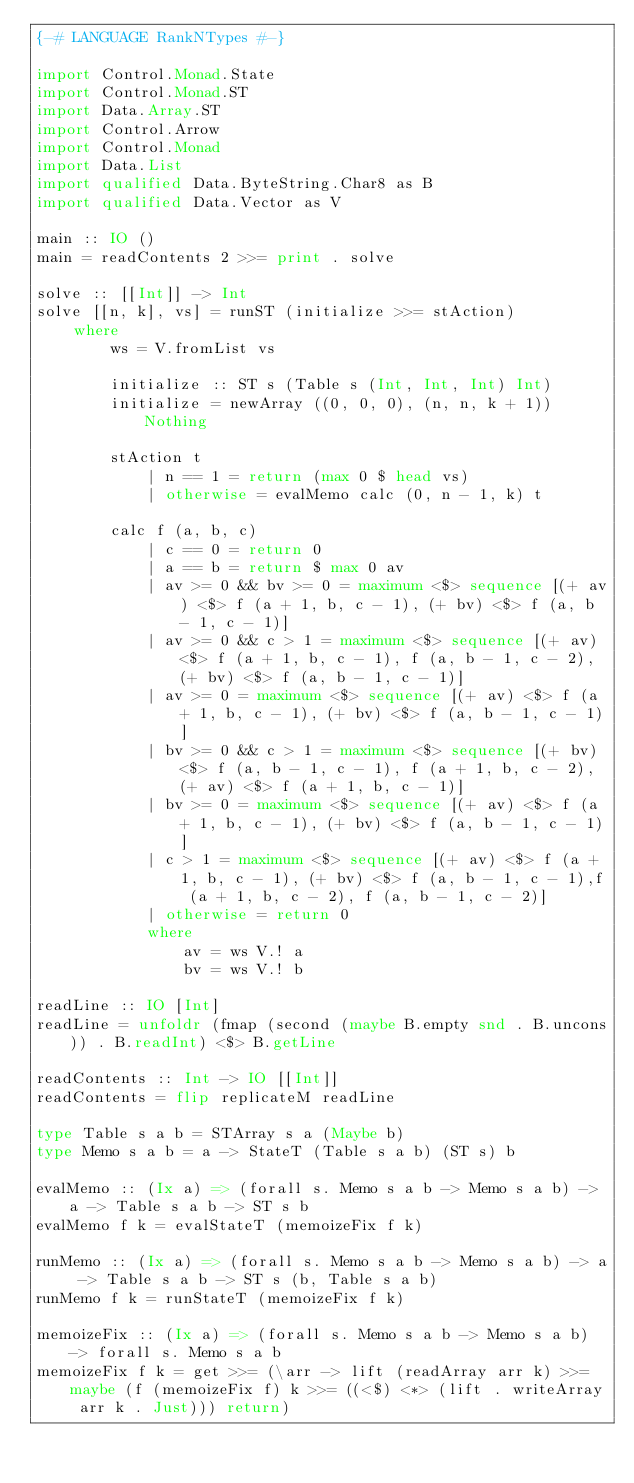Convert code to text. <code><loc_0><loc_0><loc_500><loc_500><_Haskell_>{-# LANGUAGE RankNTypes #-}
    
import Control.Monad.State
import Control.Monad.ST
import Data.Array.ST
import Control.Arrow
import Control.Monad
import Data.List
import qualified Data.ByteString.Char8 as B
import qualified Data.Vector as V

main :: IO ()
main = readContents 2 >>= print . solve

solve :: [[Int]] -> Int
solve [[n, k], vs] = runST (initialize >>= stAction)
    where
        ws = V.fromList vs

        initialize :: ST s (Table s (Int, Int, Int) Int)
        initialize = newArray ((0, 0, 0), (n, n, k + 1)) Nothing
        
        stAction t 
            | n == 1 = return (max 0 $ head vs)
            | otherwise = evalMemo calc (0, n - 1, k) t 

        calc f (a, b, c)
            | c == 0 = return 0
            | a == b = return $ max 0 av 
            | av >= 0 && bv >= 0 = maximum <$> sequence [(+ av) <$> f (a + 1, b, c - 1), (+ bv) <$> f (a, b - 1, c - 1)]
            | av >= 0 && c > 1 = maximum <$> sequence [(+ av) <$> f (a + 1, b, c - 1), f (a, b - 1, c - 2), (+ bv) <$> f (a, b - 1, c - 1)]
            | av >= 0 = maximum <$> sequence [(+ av) <$> f (a + 1, b, c - 1), (+ bv) <$> f (a, b - 1, c - 1)]
            | bv >= 0 && c > 1 = maximum <$> sequence [(+ bv) <$> f (a, b - 1, c - 1), f (a + 1, b, c - 2), (+ av) <$> f (a + 1, b, c - 1)]
            | bv >= 0 = maximum <$> sequence [(+ av) <$> f (a + 1, b, c - 1), (+ bv) <$> f (a, b - 1, c - 1)]
            | c > 1 = maximum <$> sequence [(+ av) <$> f (a + 1, b, c - 1), (+ bv) <$> f (a, b - 1, c - 1),f (a + 1, b, c - 2), f (a, b - 1, c - 2)]
            | otherwise = return 0
            where
                av = ws V.! a
                bv = ws V.! b

readLine :: IO [Int]
readLine = unfoldr (fmap (second (maybe B.empty snd . B.uncons)) . B.readInt) <$> B.getLine

readContents :: Int -> IO [[Int]]
readContents = flip replicateM readLine

type Table s a b = STArray s a (Maybe b)
type Memo s a b = a -> StateT (Table s a b) (ST s) b

evalMemo :: (Ix a) => (forall s. Memo s a b -> Memo s a b) -> a -> Table s a b -> ST s b
evalMemo f k = evalStateT (memoizeFix f k)

runMemo :: (Ix a) => (forall s. Memo s a b -> Memo s a b) -> a -> Table s a b -> ST s (b, Table s a b)
runMemo f k = runStateT (memoizeFix f k)

memoizeFix :: (Ix a) => (forall s. Memo s a b -> Memo s a b) -> forall s. Memo s a b
memoizeFix f k = get >>= (\arr -> lift (readArray arr k) >>= maybe (f (memoizeFix f) k >>= ((<$) <*> (lift . writeArray arr k . Just))) return)</code> 